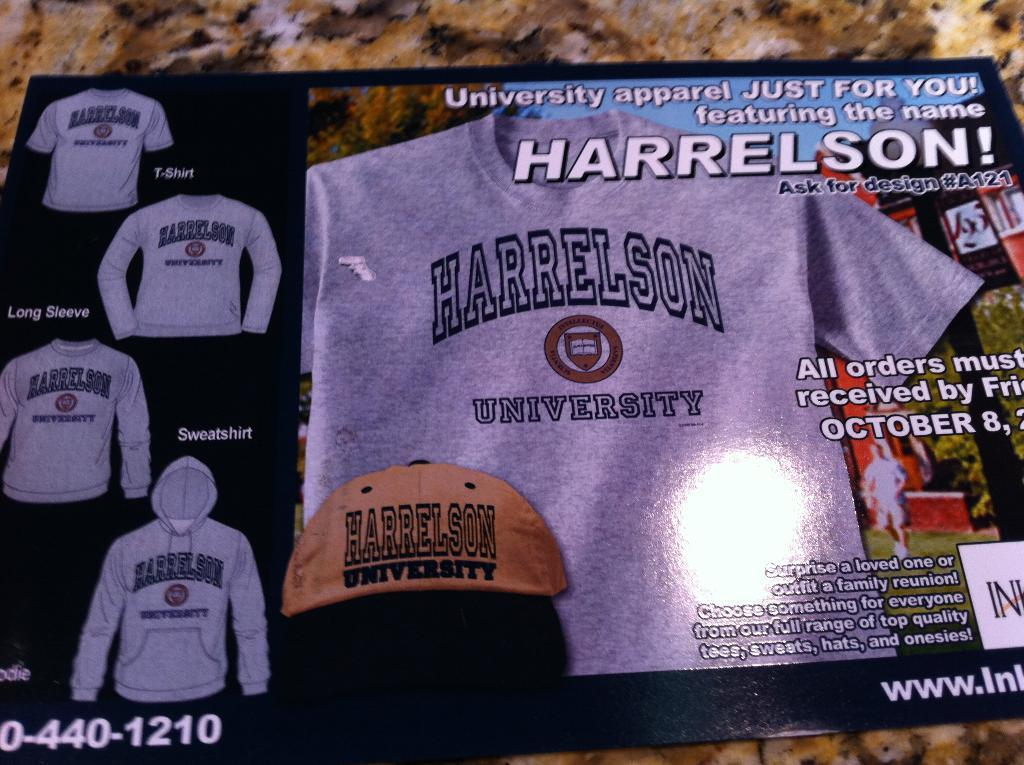<image>
Provide a brief description of the given image. An advertisement for Harrelson University apparel including shirts, sweatshirts and hats. 